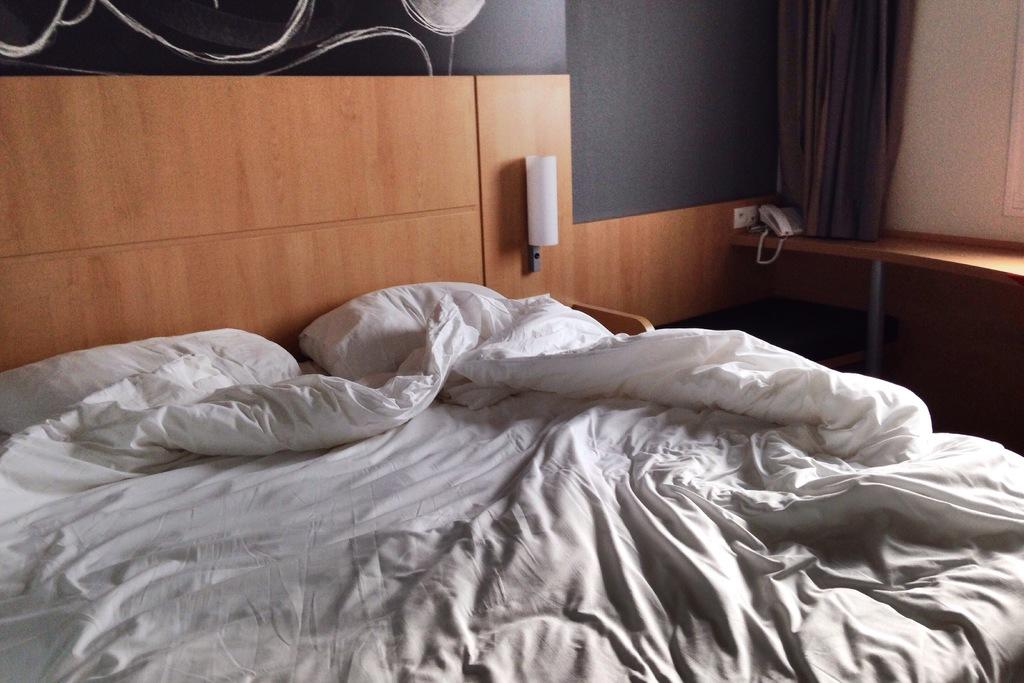Where was the image taken? The image was taken inside a room. What is the main piece of furniture in the room? There is a bed in the middle of the room. What is covering the bed? There is a bed sheet on the bed. What is used for head support on the bed? There are pillows on the bed. What is on the right side of the room? There is a table on the right side of the room. What is on the table? There is a telephone on the table. What is present in the room to provide privacy? There is a curtain in the room. What is the room enclosed by? There is a wall in the room. What is the belief of the moon in the image? There is no moon present in the image, so it is not possible to determine any beliefs associated with it. 